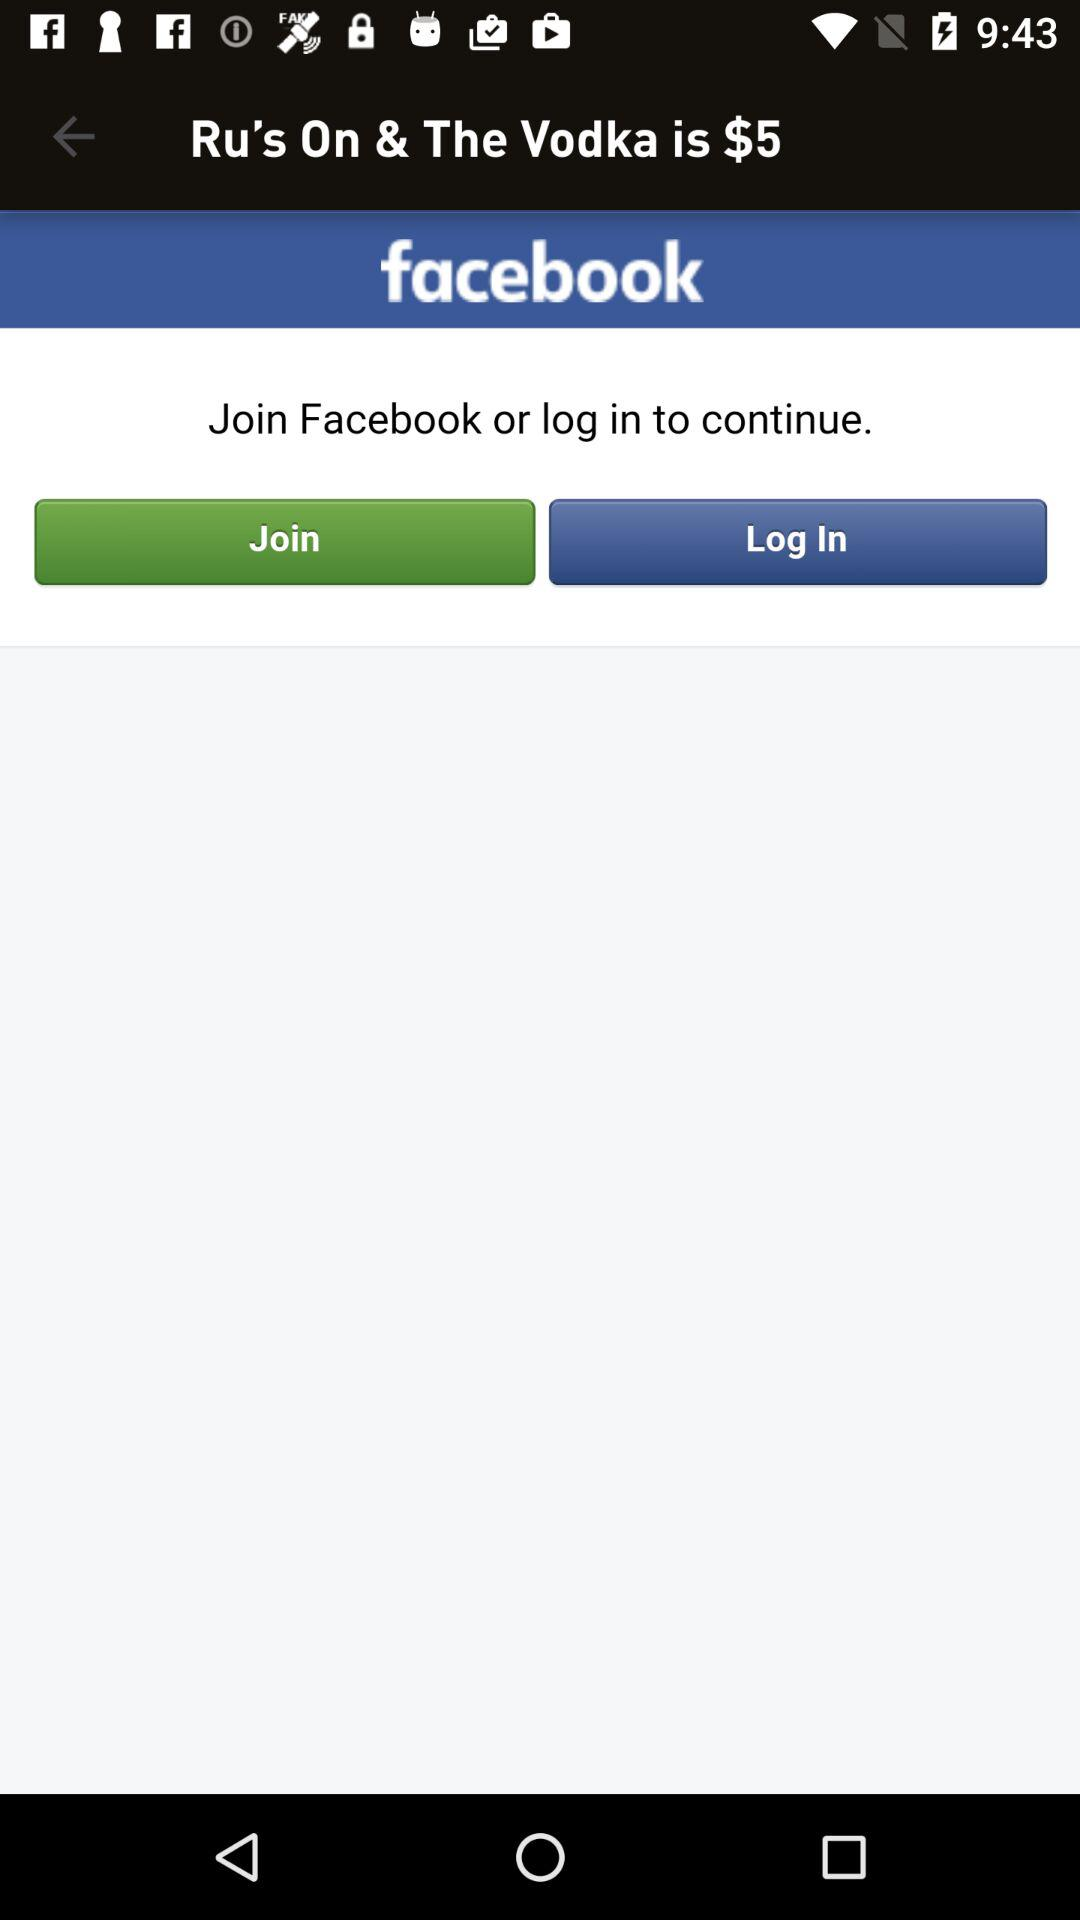What is the price of the "Ru's On & The Vodka"? The price is $5. 